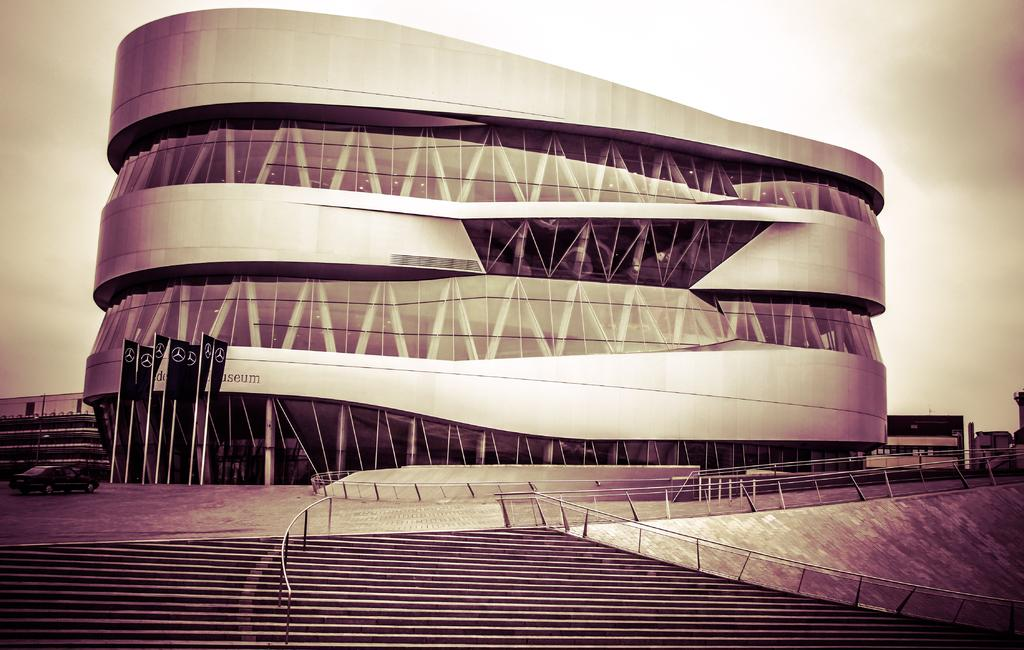What is the main structure in the center of the image? There is a building in the center of the image. What can be seen at the bottom of the image? Stairs, flags, poles, and fencing are present at the bottom of the image. What is visible in the background of the image? The sky is visible in the background of the image. Where is the brother standing in the image? There is no brother present in the image. What type of spot can be seen on the building in the image? There are no spots visible on the building in the image. 